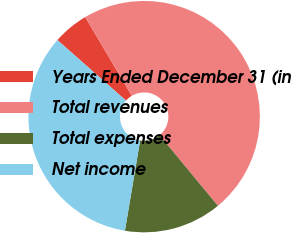<chart> <loc_0><loc_0><loc_500><loc_500><pie_chart><fcel>Years Ended December 31 (in<fcel>Total revenues<fcel>Total expenses<fcel>Net income<nl><fcel>4.99%<fcel>47.51%<fcel>13.66%<fcel>33.85%<nl></chart> 